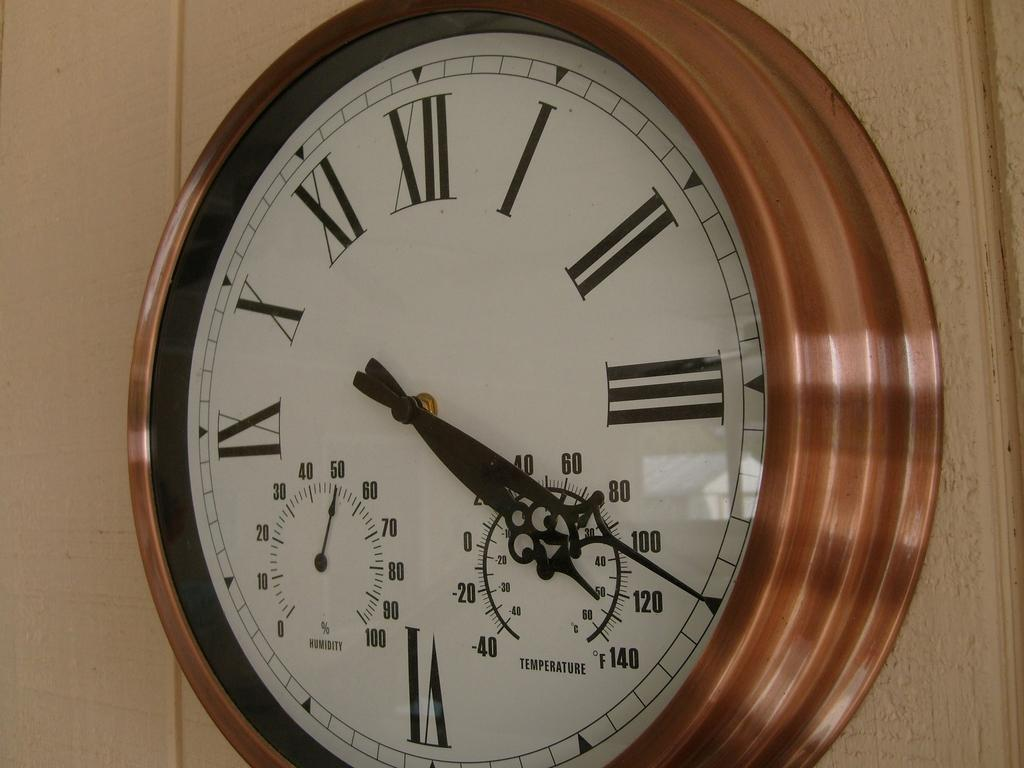<image>
Render a clear and concise summary of the photo. A multi-function clock shows the temperature and the humidity as well as the time. 